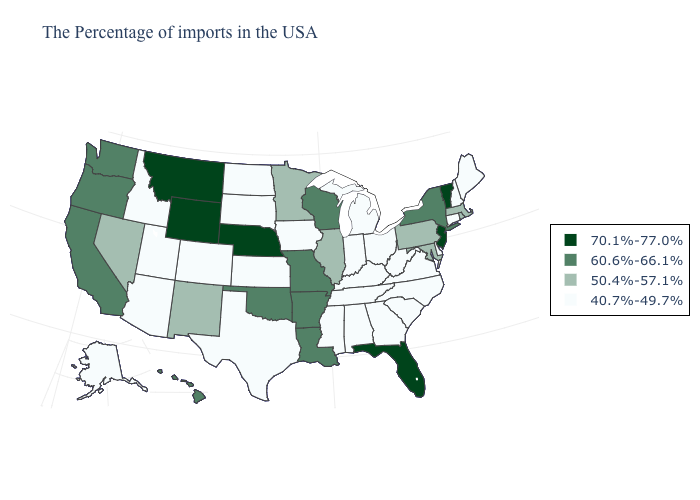Does the first symbol in the legend represent the smallest category?
Be succinct. No. What is the highest value in the USA?
Write a very short answer. 70.1%-77.0%. Name the states that have a value in the range 40.7%-49.7%?
Write a very short answer. Maine, New Hampshire, Connecticut, Delaware, Virginia, North Carolina, South Carolina, West Virginia, Ohio, Georgia, Michigan, Kentucky, Indiana, Alabama, Tennessee, Mississippi, Iowa, Kansas, Texas, South Dakota, North Dakota, Colorado, Utah, Arizona, Idaho, Alaska. Name the states that have a value in the range 70.1%-77.0%?
Concise answer only. Vermont, New Jersey, Florida, Nebraska, Wyoming, Montana. What is the highest value in the Northeast ?
Answer briefly. 70.1%-77.0%. How many symbols are there in the legend?
Give a very brief answer. 4. What is the value of Oklahoma?
Short answer required. 60.6%-66.1%. What is the highest value in the MidWest ?
Concise answer only. 70.1%-77.0%. Which states have the lowest value in the USA?
Answer briefly. Maine, New Hampshire, Connecticut, Delaware, Virginia, North Carolina, South Carolina, West Virginia, Ohio, Georgia, Michigan, Kentucky, Indiana, Alabama, Tennessee, Mississippi, Iowa, Kansas, Texas, South Dakota, North Dakota, Colorado, Utah, Arizona, Idaho, Alaska. What is the value of Alaska?
Give a very brief answer. 40.7%-49.7%. Among the states that border New Mexico , which have the highest value?
Quick response, please. Oklahoma. What is the value of North Carolina?
Write a very short answer. 40.7%-49.7%. Does the first symbol in the legend represent the smallest category?
Quick response, please. No. Name the states that have a value in the range 60.6%-66.1%?
Short answer required. New York, Wisconsin, Louisiana, Missouri, Arkansas, Oklahoma, California, Washington, Oregon, Hawaii. What is the highest value in the USA?
Write a very short answer. 70.1%-77.0%. 